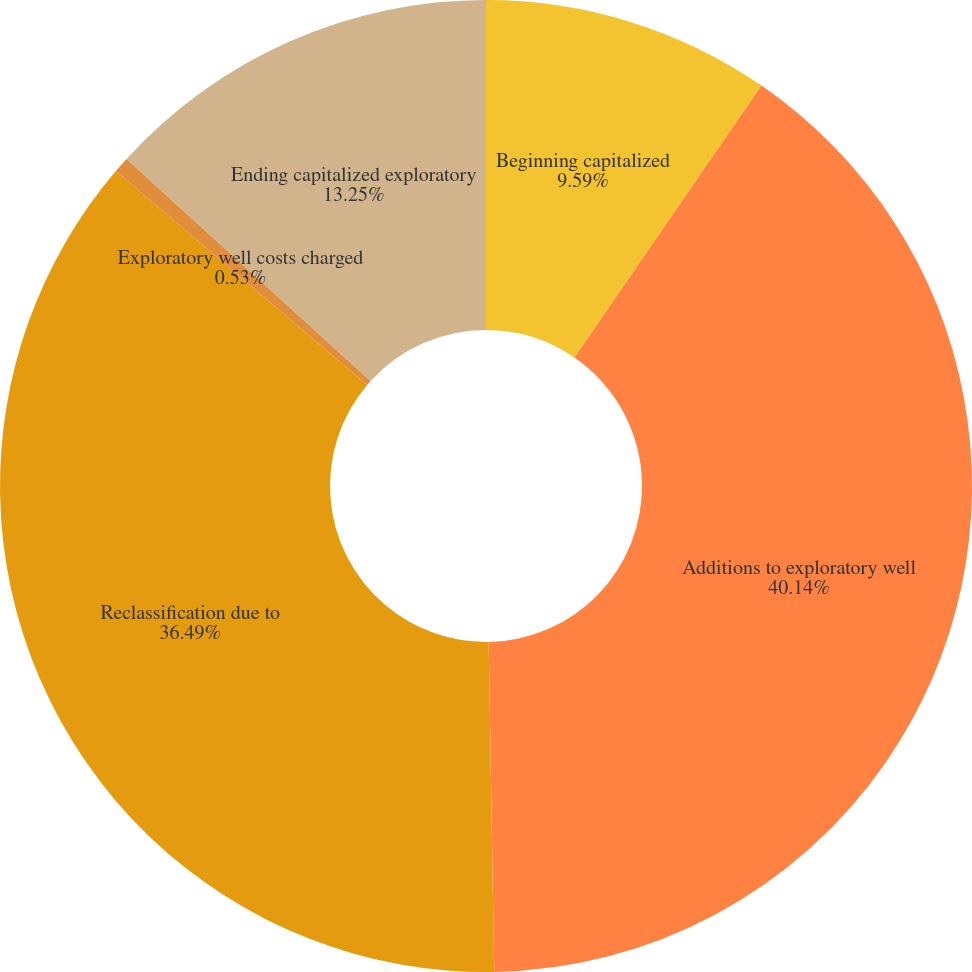Convert chart. <chart><loc_0><loc_0><loc_500><loc_500><pie_chart><fcel>Beginning capitalized<fcel>Additions to exploratory well<fcel>Reclassification due to<fcel>Exploratory well costs charged<fcel>Ending capitalized exploratory<nl><fcel>9.59%<fcel>40.14%<fcel>36.49%<fcel>0.53%<fcel>13.25%<nl></chart> 